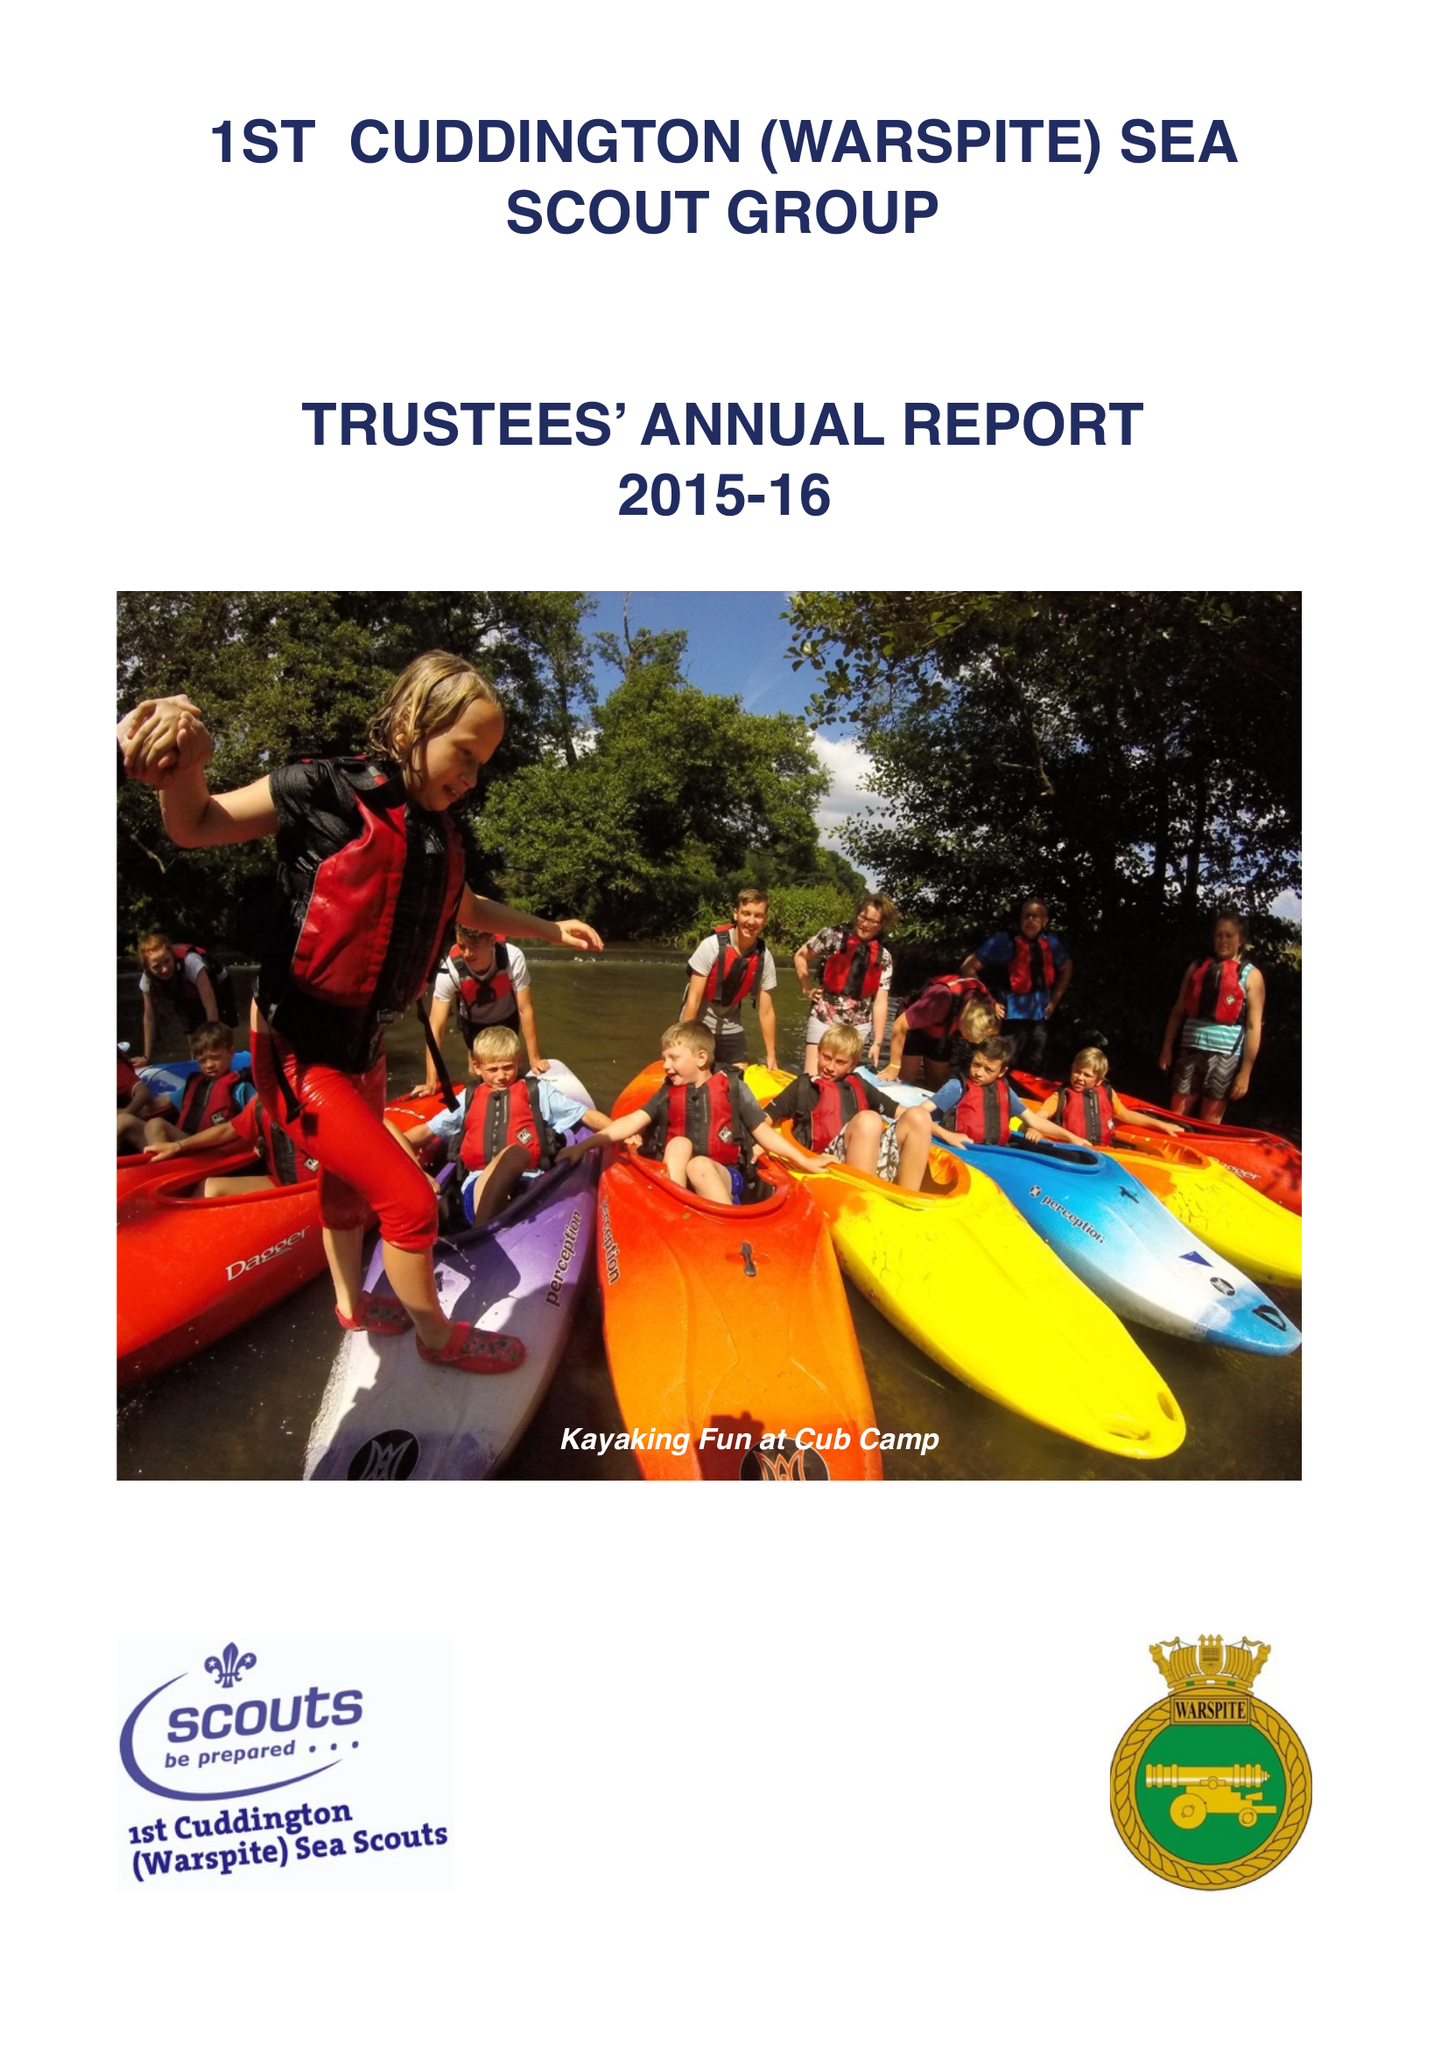What is the value for the spending_annually_in_british_pounds?
Answer the question using a single word or phrase. 78677.00 